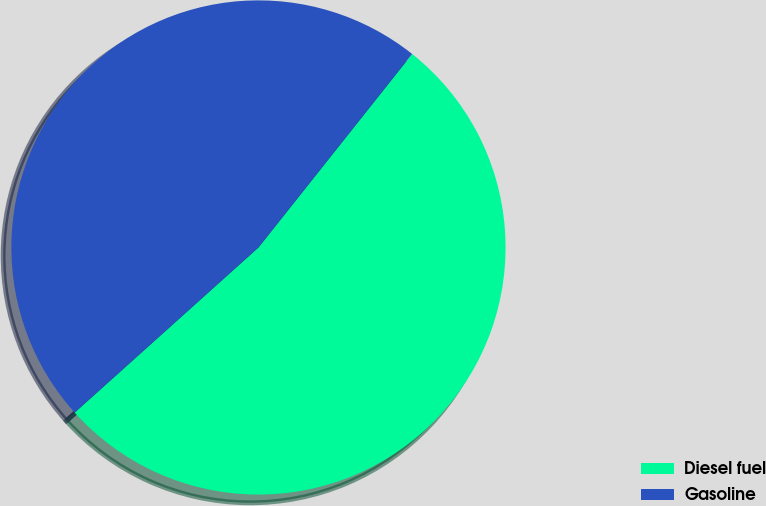Convert chart to OTSL. <chart><loc_0><loc_0><loc_500><loc_500><pie_chart><fcel>Diesel fuel<fcel>Gasoline<nl><fcel>52.67%<fcel>47.33%<nl></chart> 